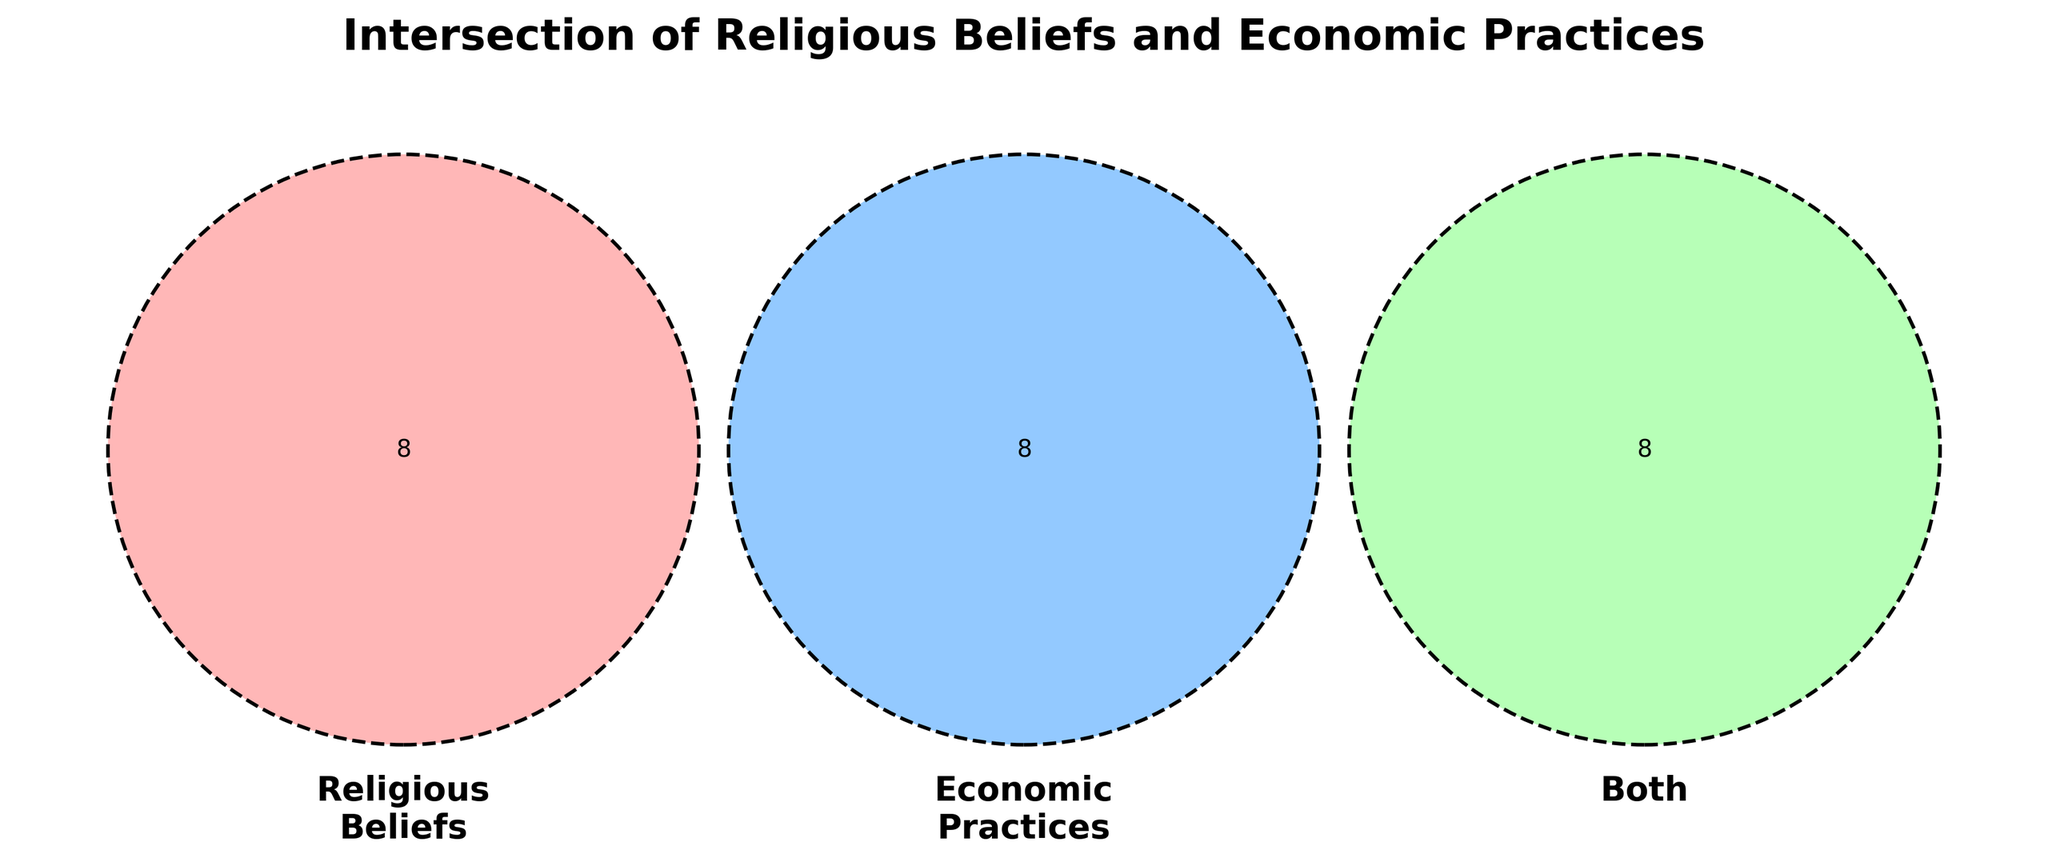What are the three categories labeled in the Venn Diagram? The categories are labeled as "Religious Beliefs," "Economic Practices," and "Both." Each category corresponds to one circle in the Venn Diagram.
Answer: Religious Beliefs, Economic Practices, Both How many items are listed under the "Both" category? By looking at the "Both" section where the circles overlap, we can count the items listed there. There are eight items listed under "Both."
Answer: Eight Which category contains the term "Entrepreneurship"? The term "Entrepreneurship" is listed in the circle labeled "Economic Practices."
Answer: Economic Practices How many unique items are there in total across all categories? Count all the unique items in the combined three categories. The items are: Monasticism, Pilgrimage, Tithing, Asceticism, Sabbath, Religious festivals, Sacred texts, Afterlife beliefs, Market economy, Trade routes, Capital investment, Economic growth, Labor laws, Supply and demand, Capitalism, Work ethic, Usury laws, Charity, Islamic banking, Fair trade, Protestant work ethic, Zakat, Weber's Protestant Ethic thesis. There are 23 unique items in total.
Answer: 23 Which item appears in the intersection of "Religious Beliefs" and "Economic Practices"? The only item that appears in the intersection of these two categories is "Work ethic," as it belongs to both categories.
Answer: Work ethic Are there more items in "Religious Beliefs" or "Economic Practices"? Count the items in each category: "Religious Beliefs" has 8 items and "Economic Practices" has 8 items. Therefore, they have an equal number.
Answer: Equal number of items What economic practice is linked to religious fasts? "Religious festivals" fall under "Religious Beliefs" and its linked economic practice is "Supply and demand."
Answer: Supply and demand How many items are related to laws and regulations? The related items are: "Labor laws," "Usury laws," "Fair trade," and "Islamic banking." There are four items related to laws and regulations.
Answer: Four 